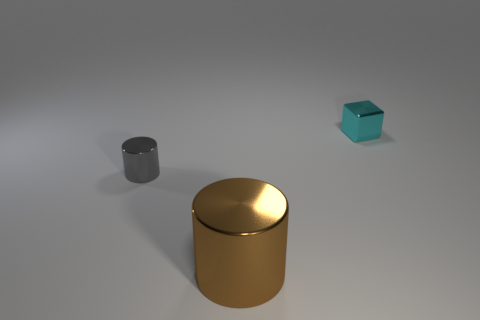Add 3 big red matte balls. How many objects exist? 6 Subtract all blocks. How many objects are left? 2 Subtract 0 purple spheres. How many objects are left? 3 Subtract all gray cylinders. Subtract all red blocks. How many cylinders are left? 1 Subtract all big yellow shiny cylinders. Subtract all tiny cylinders. How many objects are left? 2 Add 1 tiny objects. How many tiny objects are left? 3 Add 1 small cyan metallic objects. How many small cyan metallic objects exist? 2 